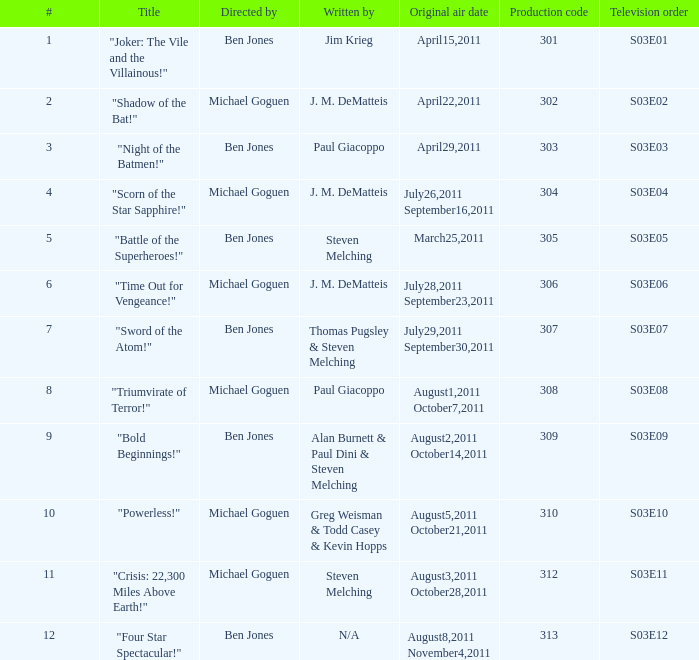What was the original air date for "Crisis: 22,300 Miles Above Earth!"? August3,2011 October28,2011. 